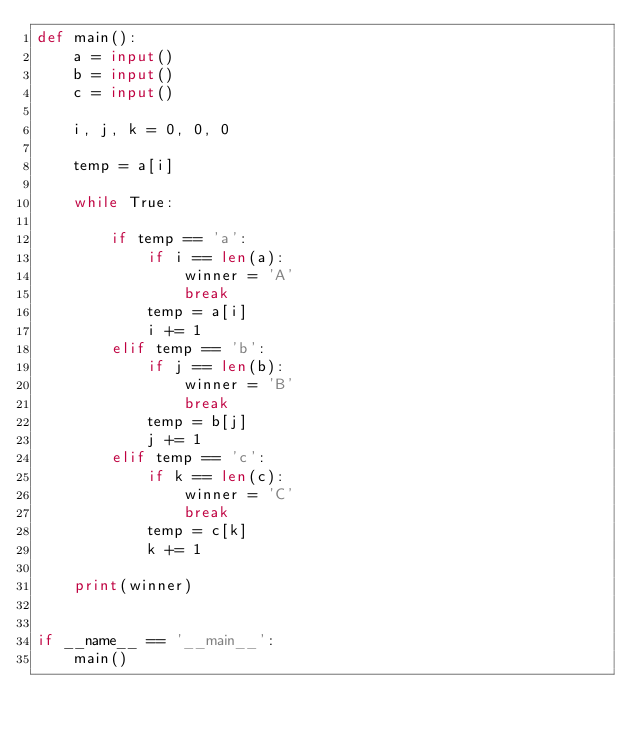<code> <loc_0><loc_0><loc_500><loc_500><_Python_>def main():
    a = input()
    b = input()
    c = input()

    i, j, k = 0, 0, 0

    temp = a[i]

    while True:

        if temp == 'a':
            if i == len(a):
                winner = 'A'
                break
            temp = a[i]
            i += 1
        elif temp == 'b':
            if j == len(b):
                winner = 'B'
                break
            temp = b[j]
            j += 1
        elif temp == 'c':
            if k == len(c):
                winner = 'C'
                break
            temp = c[k]
            k += 1

    print(winner)


if __name__ == '__main__':
    main()
</code> 